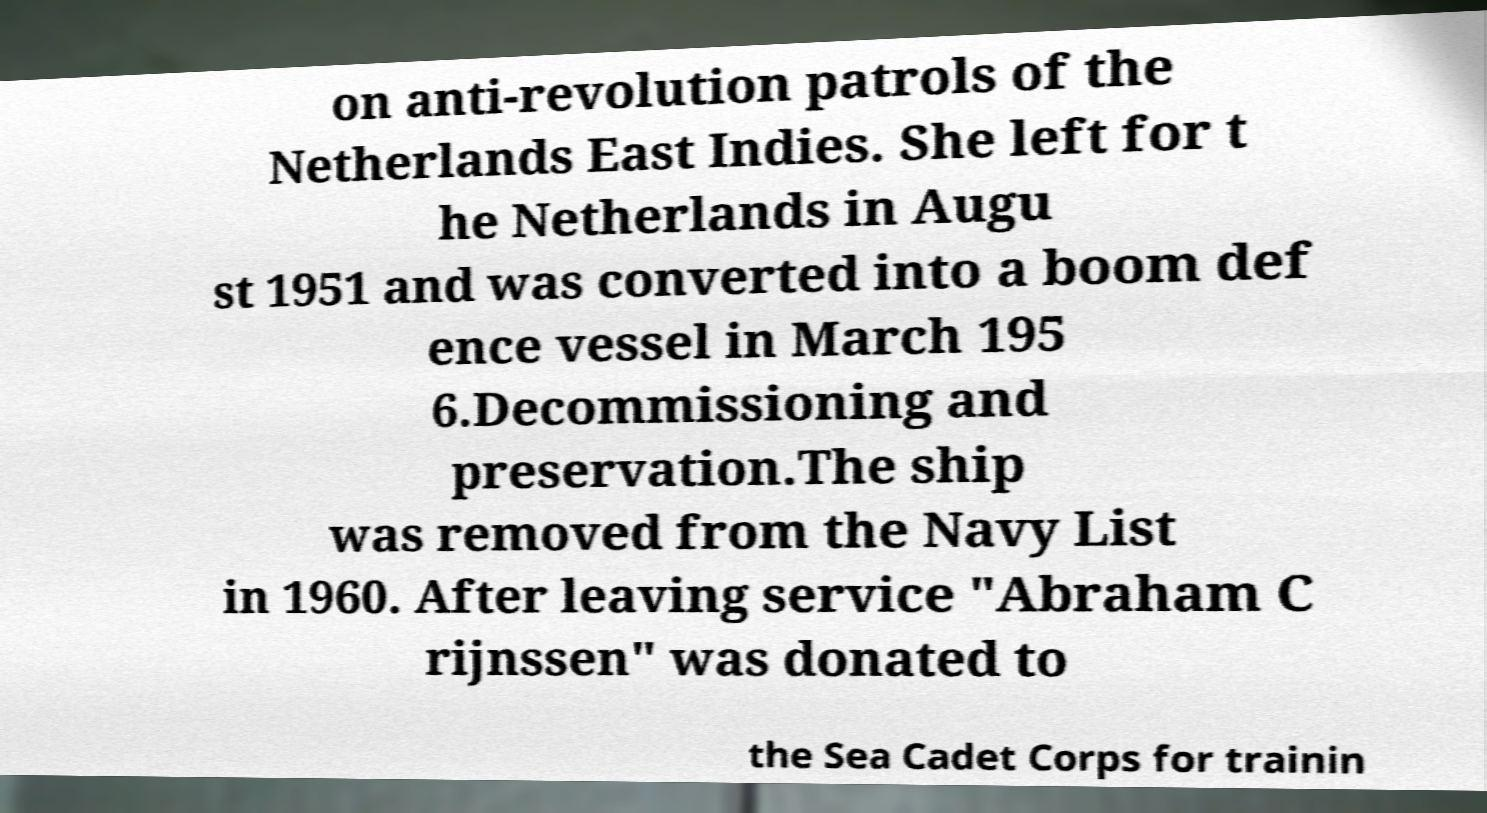Please read and relay the text visible in this image. What does it say? on anti-revolution patrols of the Netherlands East Indies. She left for t he Netherlands in Augu st 1951 and was converted into a boom def ence vessel in March 195 6.Decommissioning and preservation.The ship was removed from the Navy List in 1960. After leaving service "Abraham C rijnssen" was donated to the Sea Cadet Corps for trainin 